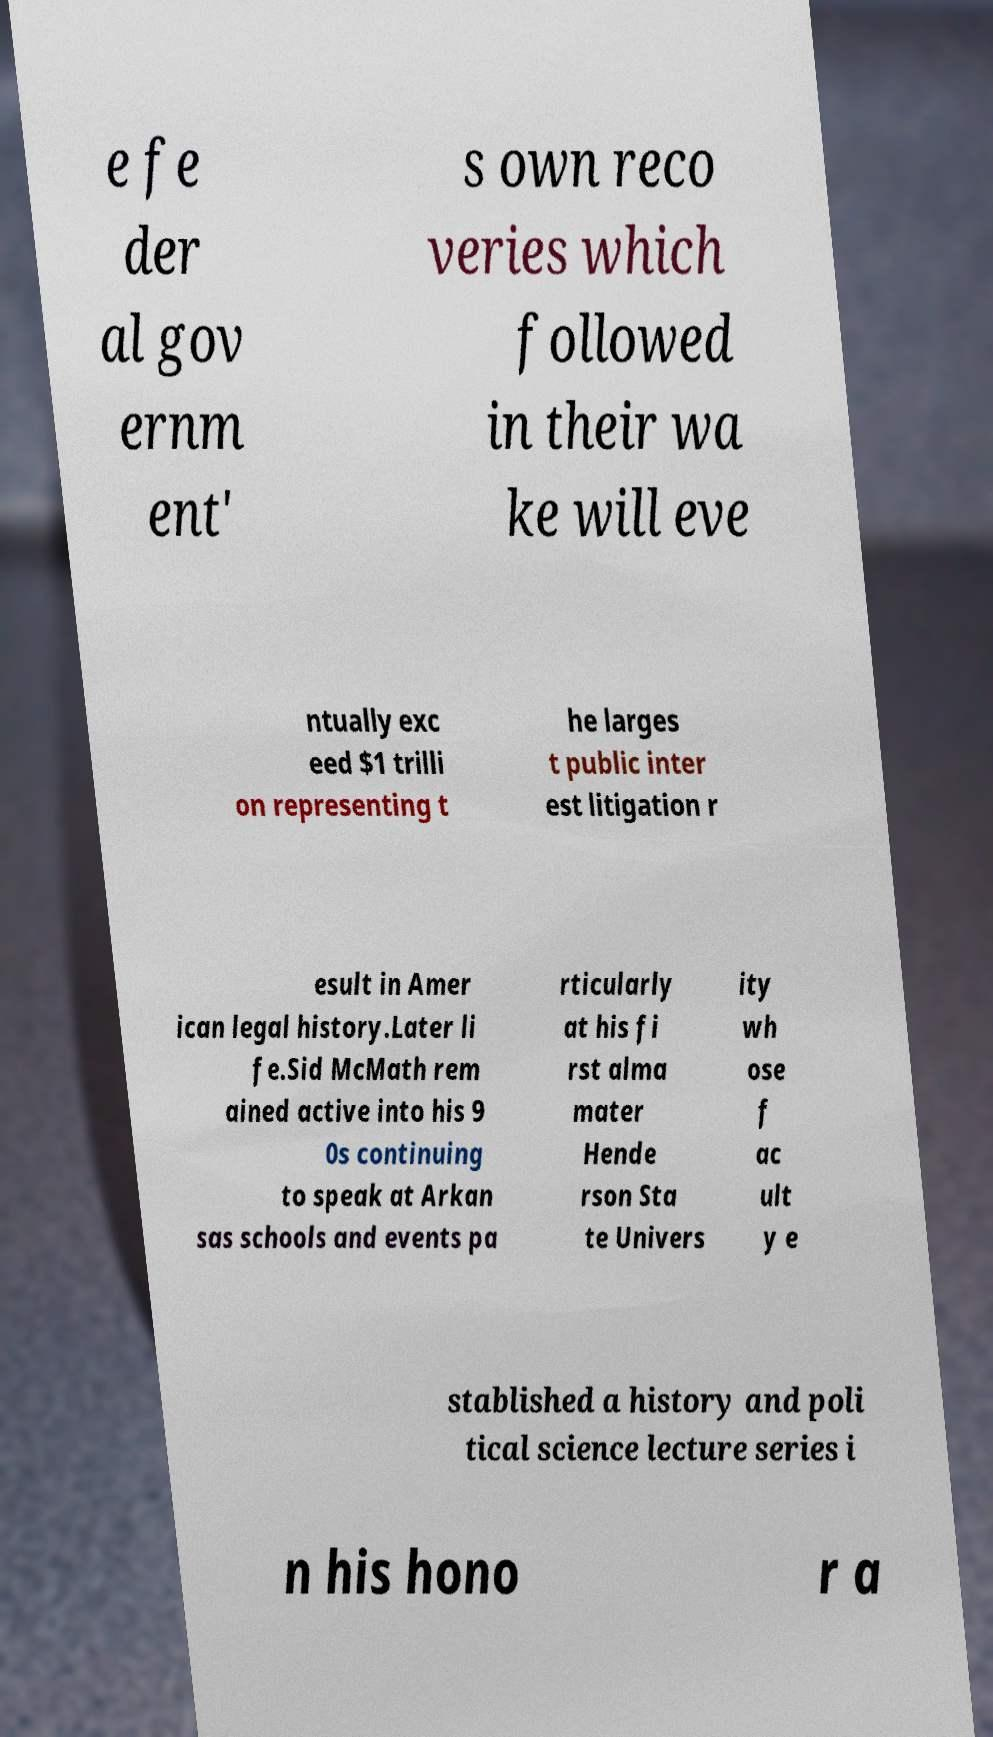Please read and relay the text visible in this image. What does it say? e fe der al gov ernm ent' s own reco veries which followed in their wa ke will eve ntually exc eed $1 trilli on representing t he larges t public inter est litigation r esult in Amer ican legal history.Later li fe.Sid McMath rem ained active into his 9 0s continuing to speak at Arkan sas schools and events pa rticularly at his fi rst alma mater Hende rson Sta te Univers ity wh ose f ac ult y e stablished a history and poli tical science lecture series i n his hono r a 